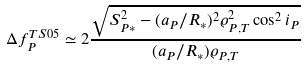Convert formula to latex. <formula><loc_0><loc_0><loc_500><loc_500>\Delta f _ { P } ^ { T S 0 5 } & \simeq 2 \frac { \sqrt { S _ { P * } ^ { 2 } - ( a _ { P } / R _ { * } ) ^ { 2 } \varrho _ { P , T } ^ { 2 } \cos ^ { 2 } i _ { P } } } { ( a _ { P } / R _ { * } ) \varrho _ { P , T } }</formula> 